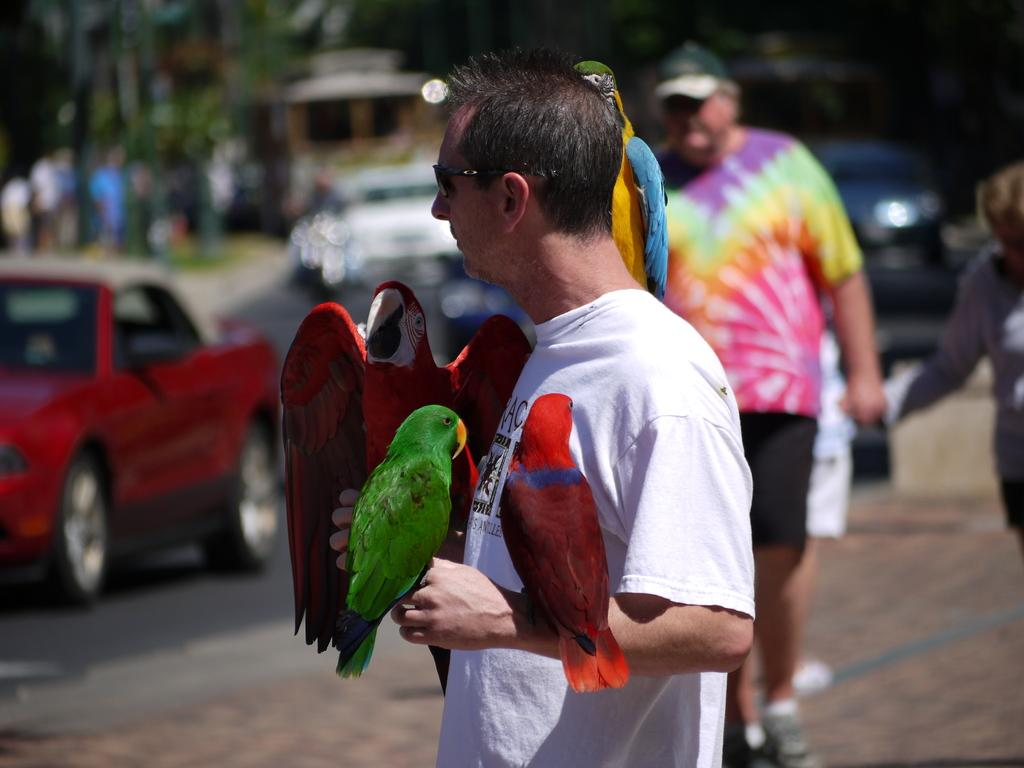Who is the main subject in the front of the image? There is a man standing in the front of the image. What animals are present in the image? There are four parrots in the image. What can be seen in the background of the image? There are cars traveling on the road and trees visible in the background of the image. What type of string is being used to play chess in the image? There is no string or chess game present in the image. 